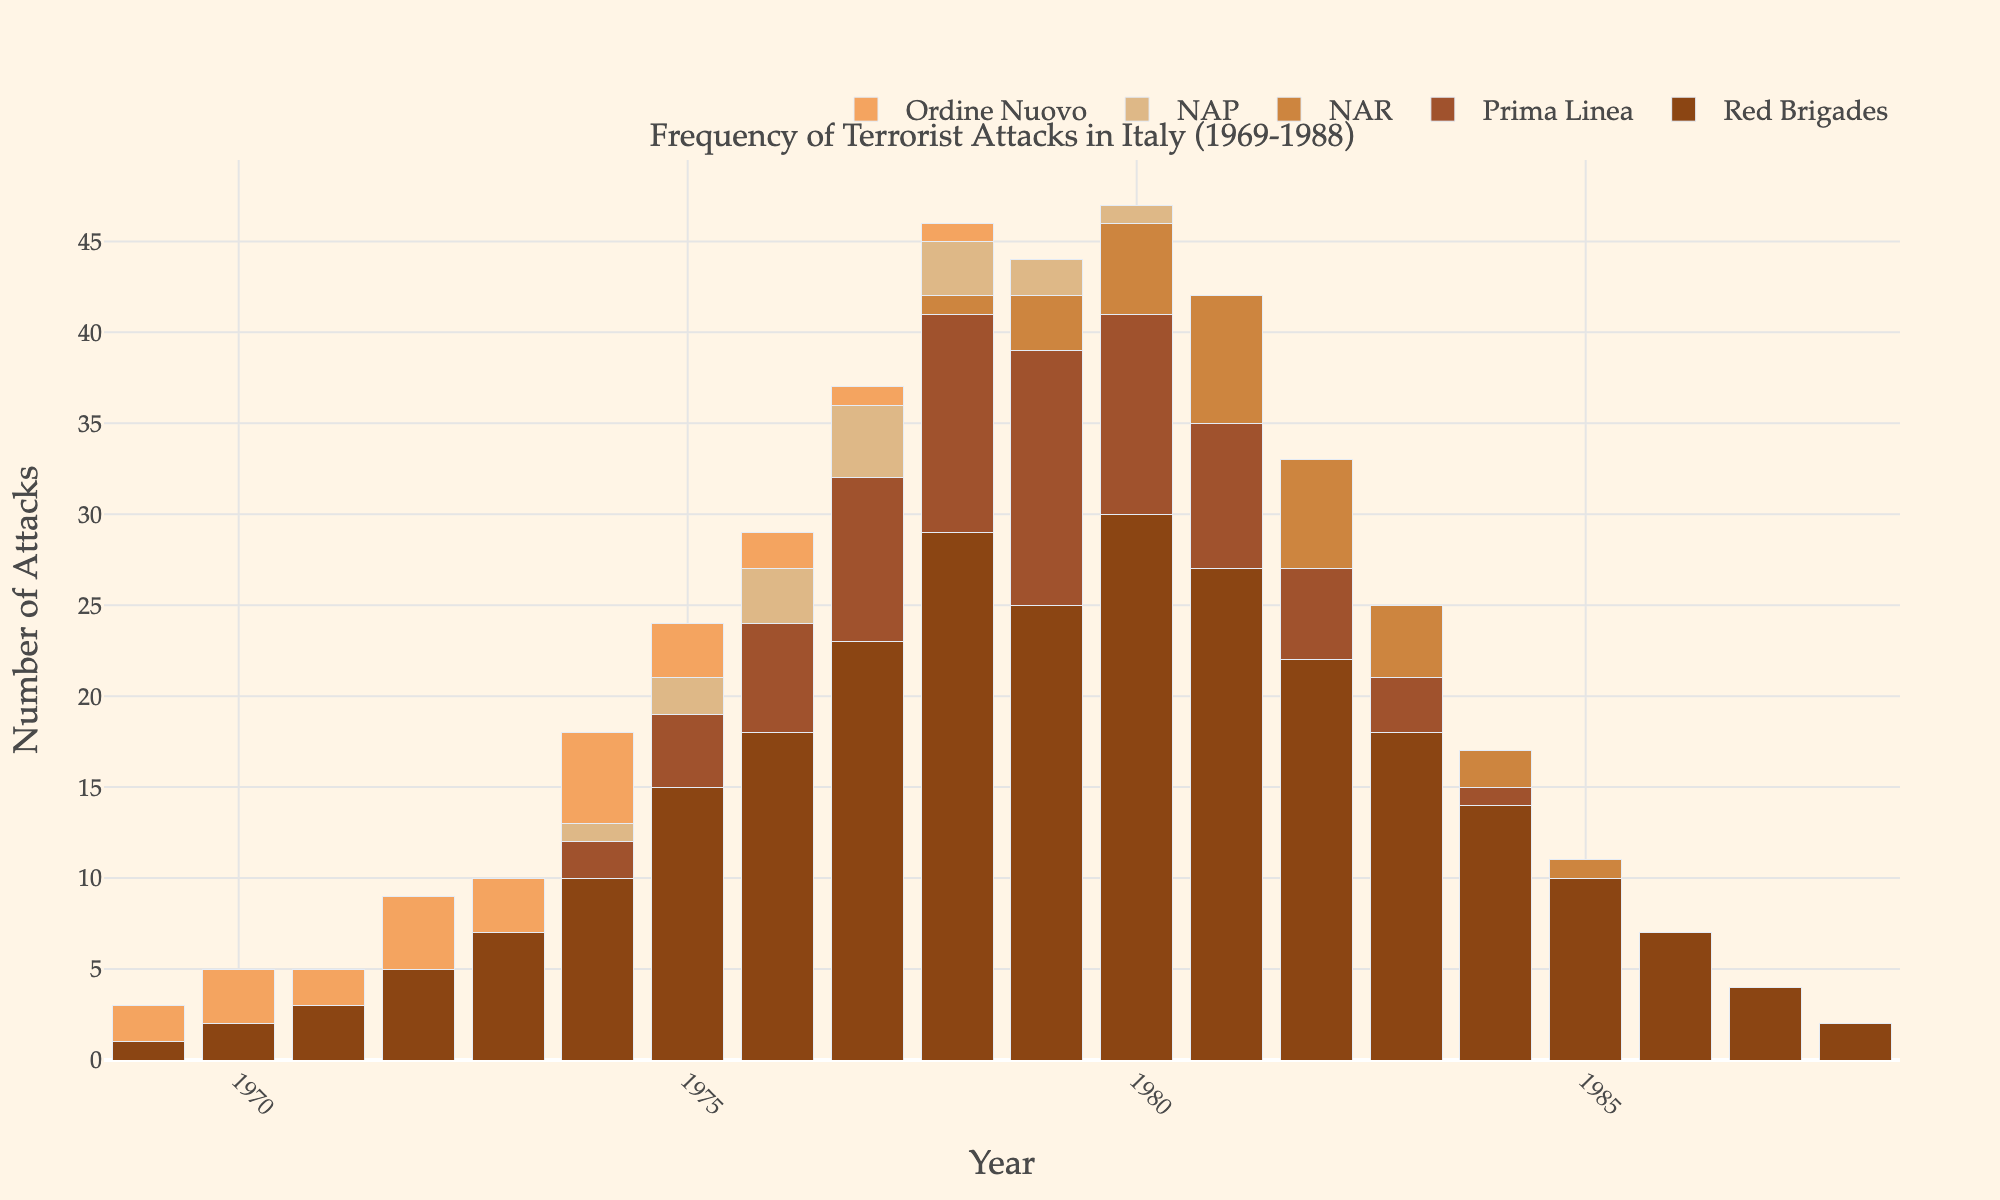Which extremist group had the most attacks in 1980? By looking at the bar corresponding to the year 1980, the height of the bars for each group is compared. The Red Brigades have the highest bar height.
Answer: Red Brigades What was the total number of attacks in 1982? Sum the heights of all the bars in the year 1982 for each extremist group: 22 (Red Brigades) + 5 (Prima Linea) + 6 (NAR) + 0 (NAP) + 0 (Ordine Nuovo) = 33.
Answer: 33 Between which years did the Red Brigades see their highest increase in attacks? Calculate the difference in the number of attacks year-on-year for the Red Brigades and observe which year pair has the highest increase. The highest increase is from 1977 (23) to 1978 (29), giving an increase of 6.
Answer: 1977-1978 In which year were attacks by the NAR the highest, and what was the number? Identify the year with the tallest bar for the NAR, which is represented by a specific color, and check the value. The tallest bar for the NAR is in 1981 with a height of 7.
Answer: 1981, 7 Which years had no attacks by NAP? Look for years where the height of the bar for NAP is zero. The years are 1969-1973, 1981-1988.
Answer: 1969-1973, 1981-1988 How many attacks did the Red Brigades have in total during the Years of Lead? Add the number of attacks from 1969 to 1988 for the Red Brigades: \(1 + 2 + 3 + 5 + 7 + 10 + 15 + 18 + 23 + 29 + 25 + 30 + 27 + 22 + 18 + 14 + 10 + 7 + 4 + 2 = 242\).
Answer: 242 What was the total number of attacks by Ordine Nuovo over the entire period? Sum the number of attacks from 1969 to 1988 for Ordine Nuovo: \(2 + 3 + 2 + 4 + 3 + 5 + 3 + 2 + 1 + 1 + 0 + 0 + 0 + 0 + 0 + 0 + 0 + 0 + 0 + 0 = 23\).
Answer: 23 In which year did Prima Linea first appear and how many attacks did they commit? Identify the earliest year where there is a non-zero bar for Prima Linea and check the value. Prima Linea first appeared in 1974 with 2 attacks.
Answer: 1974, 2 